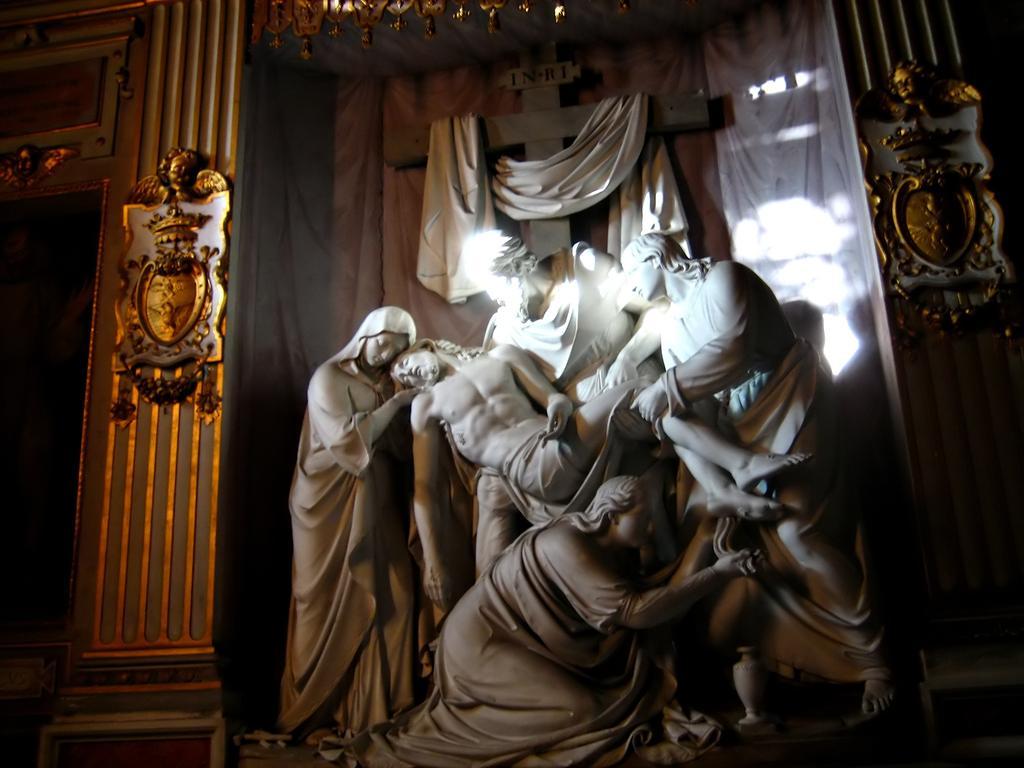Could you give a brief overview of what you see in this image? In this picture, we see the statues of the men and the women. On either side of the picture, we see the pillars. In the background, we see a white curtain and a sheet in white color. 